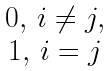Convert formula to latex. <formula><loc_0><loc_0><loc_500><loc_500>\begin{matrix} & 0 , \, i \not = j , \\ & 1 , \, i = j \end{matrix}</formula> 